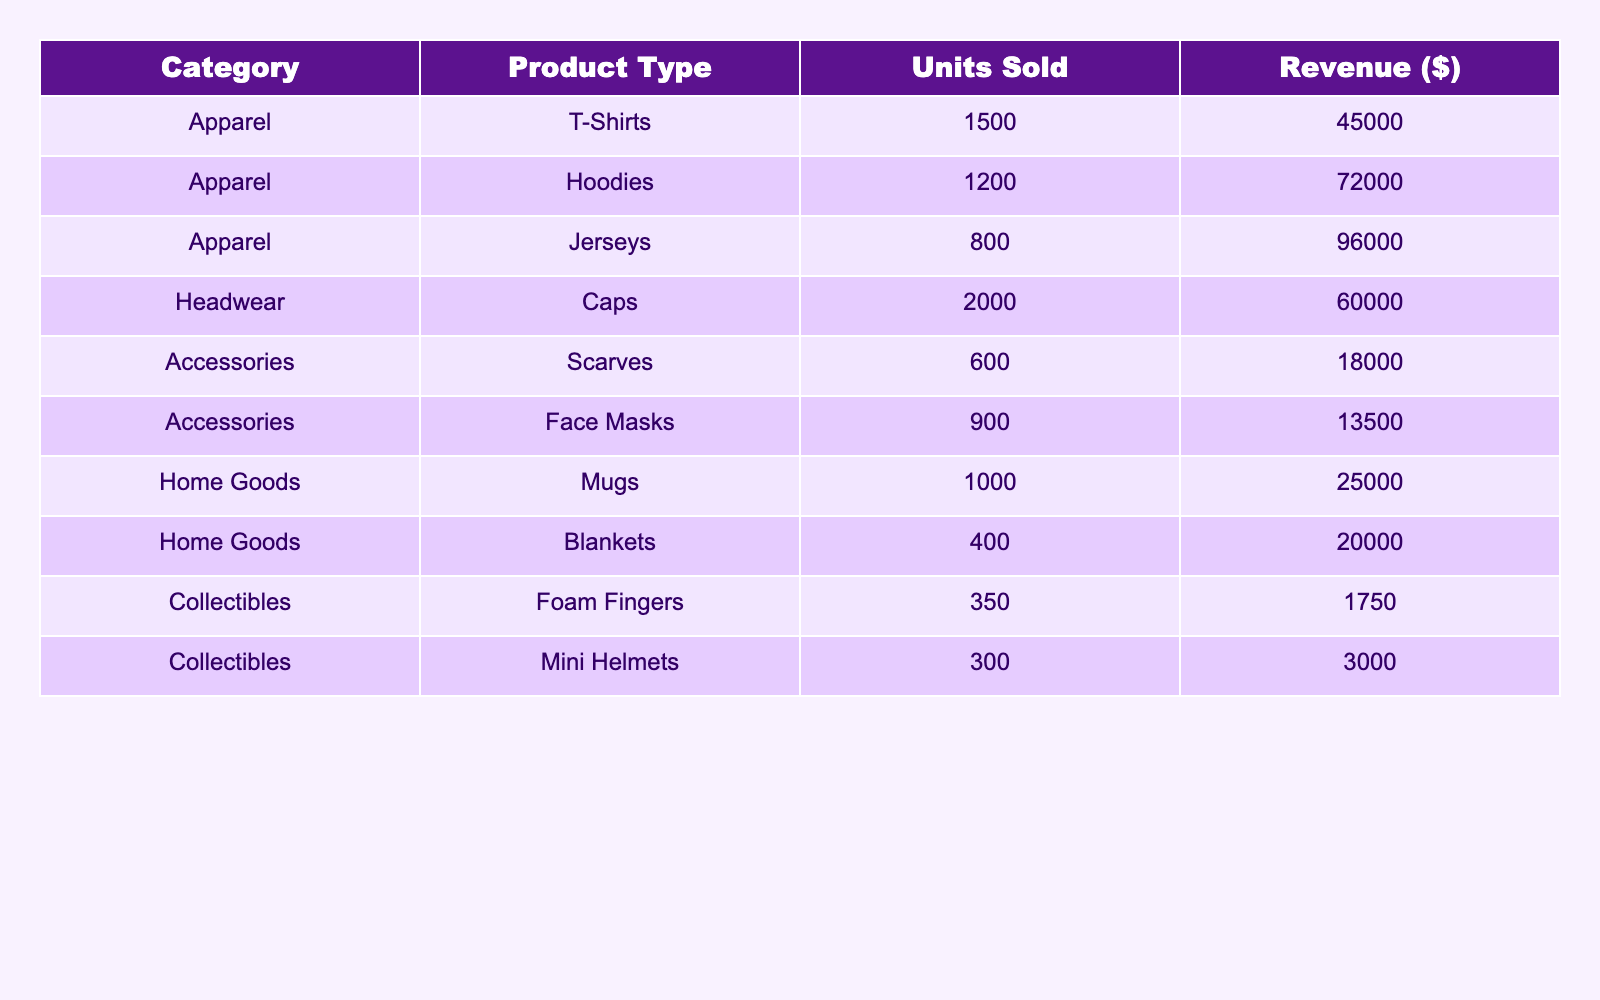What category had the highest revenue in 2023? The table shows revenues for different categories. Apparel has a total revenue of $216,000 (T-Shirts, Hoodies, and Jerseys), Headwear has $60,000 from Caps, Accessories has $31,500 from Scarves and Face Masks, Home Goods contributes $45,000 from Mugs and Blankets, and Collectibles earn $4,750 from Foam Fingers and Mini Helmets. Comparing these sums, Apparel has the highest revenue.
Answer: Apparel How many units of Caps were sold? The table directly lists the units sold for each product type. For Caps, it specifies that 2,000 units were sold.
Answer: 2000 What is the total revenue from Accessories? To find the total revenue from Accessories, we look at the revenue for Scarves ($18,000) and Face Masks ($13,500). Adding these two amounts gives us $18,000 + $13,500 = $31,500.
Answer: 31500 Did the Baltimore Ravens sell more than 1,000 units of any apparel? Looking at the apparel section, T-Shirts sold 1,500 units, Hoodies sold 1,200 units, and Jerseys sold 800 units. Both T-Shirts and Hoodies sold more than 1,000 units, so the answer is yes.
Answer: Yes What is the average revenue for Home Goods items? The revenue for Home Goods consists of Mugs ($25,000) and Blankets ($20,000). Adding these revenues gives $25,000 + $20,000 = $45,000. To find the average, divide by 2 (the number of items), resulting in $45,000 / 2 = $22,500.
Answer: 22500 Which product type sold the least units in 2023? By examining the units sold in the table, we see that Collectibles have the lowest selling items with Foam Fingers at 350 units and Mini Helmets at 300 units. Mini Helmets sold less than any other product type.
Answer: Mini Helmets What was the total revenue generated from T-Shirts and Hoodies combined? The revenue from T-Shirts is $45,000 and from Hoodies is $72,000. To find the combined total, we add these two amounts: $45,000 + $72,000 = $117,000.
Answer: 117000 Is the total revenue from Collectibles less than $5,000? The total revenue from Collectibles is $1,750 (Foam Fingers) + $3,000 (Mini Helmets) = $4,750. Since $4,750 is less than $5,000, the answer is yes.
Answer: Yes 